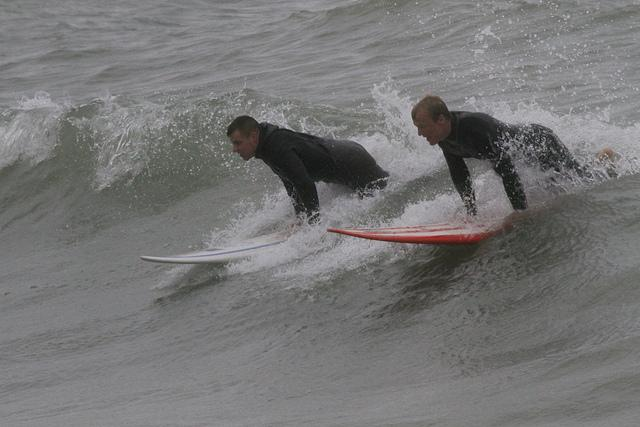What are the men on the boards attempting to do? surf 